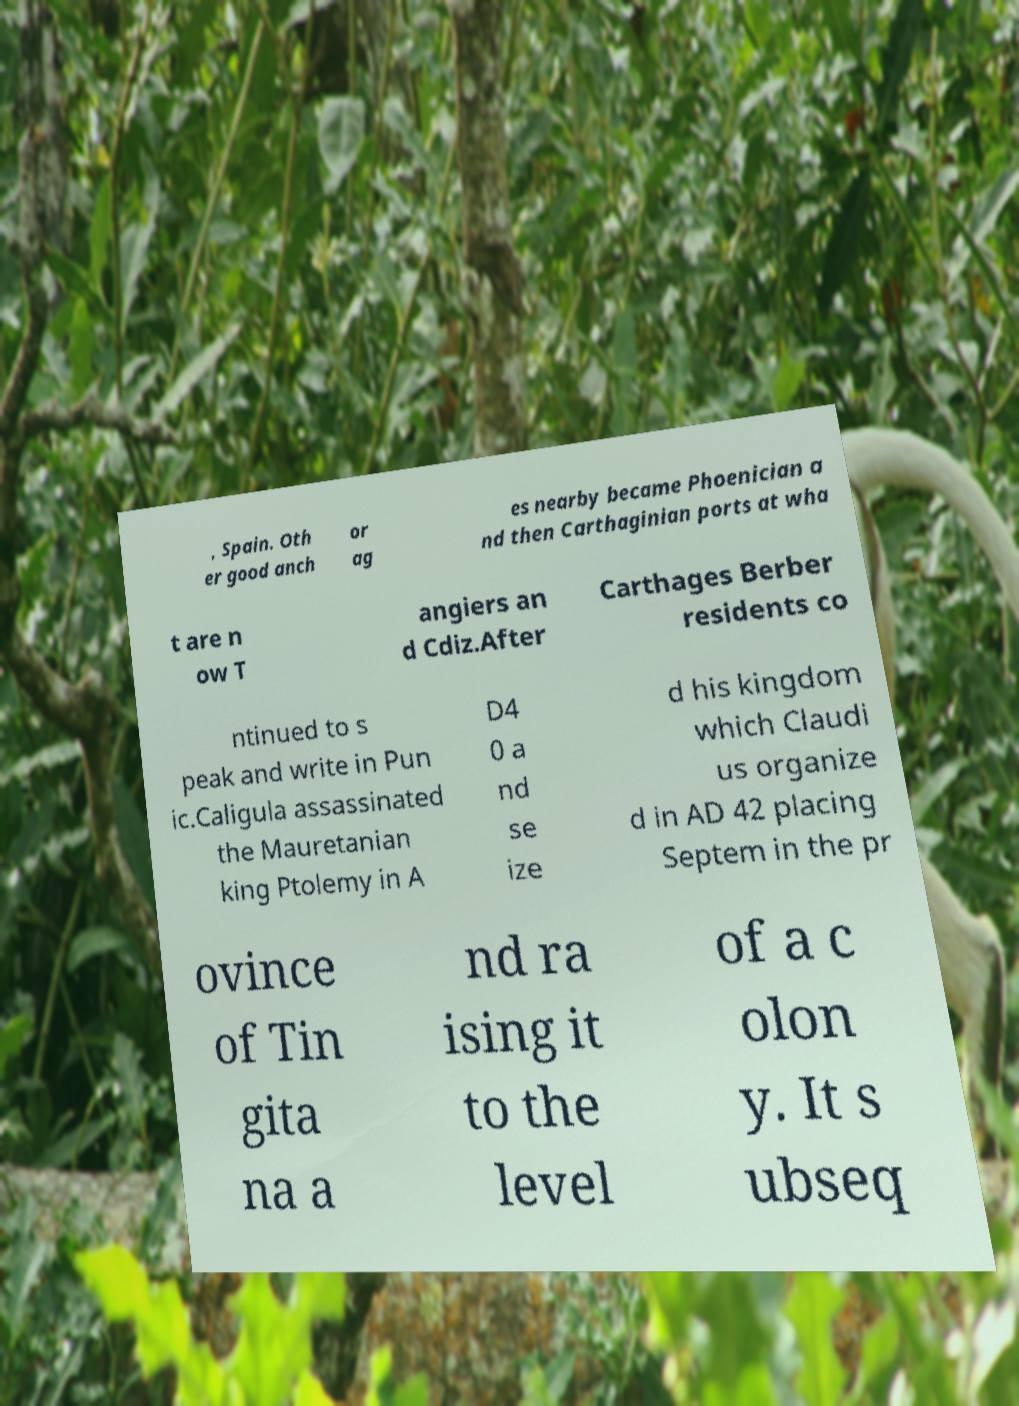There's text embedded in this image that I need extracted. Can you transcribe it verbatim? , Spain. Oth er good anch or ag es nearby became Phoenician a nd then Carthaginian ports at wha t are n ow T angiers an d Cdiz.After Carthages Berber residents co ntinued to s peak and write in Pun ic.Caligula assassinated the Mauretanian king Ptolemy in A D4 0 a nd se ize d his kingdom which Claudi us organize d in AD 42 placing Septem in the pr ovince of Tin gita na a nd ra ising it to the level of a c olon y. It s ubseq 